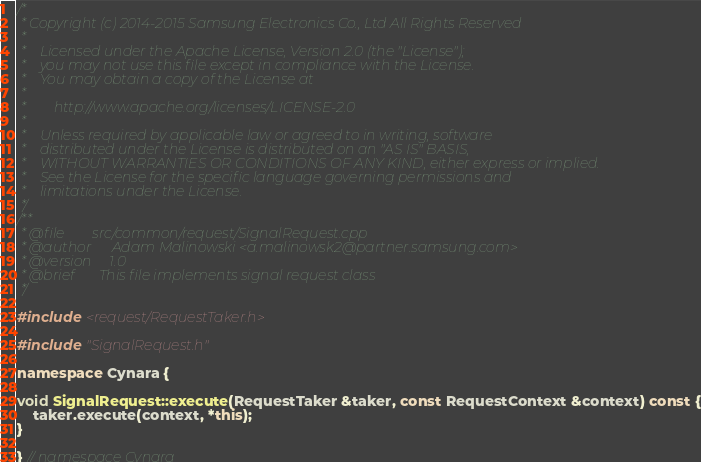<code> <loc_0><loc_0><loc_500><loc_500><_C++_>/*
 * Copyright (c) 2014-2015 Samsung Electronics Co., Ltd All Rights Reserved
 *
 *    Licensed under the Apache License, Version 2.0 (the "License");
 *    you may not use this file except in compliance with the License.
 *    You may obtain a copy of the License at
 *
 *        http://www.apache.org/licenses/LICENSE-2.0
 *
 *    Unless required by applicable law or agreed to in writing, software
 *    distributed under the License is distributed on an "AS IS" BASIS,
 *    WITHOUT WARRANTIES OR CONDITIONS OF ANY KIND, either express or implied.
 *    See the License for the specific language governing permissions and
 *    limitations under the License.
 */
/**
 * @file        src/common/request/SignalRequest.cpp
 * @author      Adam Malinowski <a.malinowsk2@partner.samsung.com>
 * @version     1.0
 * @brief       This file implements signal request class
 */

#include <request/RequestTaker.h>

#include "SignalRequest.h"

namespace Cynara {

void SignalRequest::execute(RequestTaker &taker, const RequestContext &context) const {
    taker.execute(context, *this);
}

} // namespace Cynara
</code> 